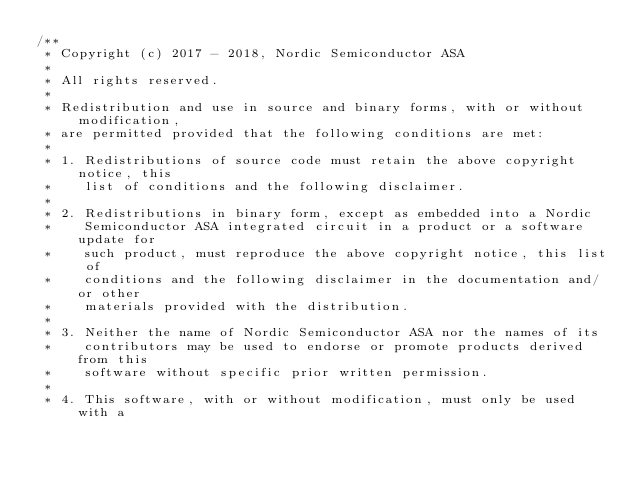<code> <loc_0><loc_0><loc_500><loc_500><_C_>/**
 * Copyright (c) 2017 - 2018, Nordic Semiconductor ASA
 *
 * All rights reserved.
 *
 * Redistribution and use in source and binary forms, with or without modification,
 * are permitted provided that the following conditions are met:
 *
 * 1. Redistributions of source code must retain the above copyright notice, this
 *    list of conditions and the following disclaimer.
 *
 * 2. Redistributions in binary form, except as embedded into a Nordic
 *    Semiconductor ASA integrated circuit in a product or a software update for
 *    such product, must reproduce the above copyright notice, this list of
 *    conditions and the following disclaimer in the documentation and/or other
 *    materials provided with the distribution.
 *
 * 3. Neither the name of Nordic Semiconductor ASA nor the names of its
 *    contributors may be used to endorse or promote products derived from this
 *    software without specific prior written permission.
 *
 * 4. This software, with or without modification, must only be used with a</code> 